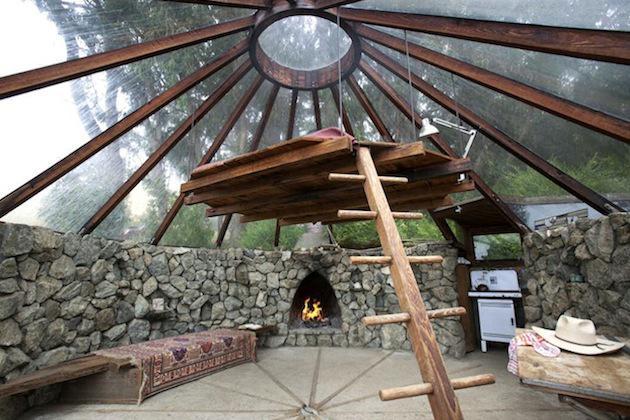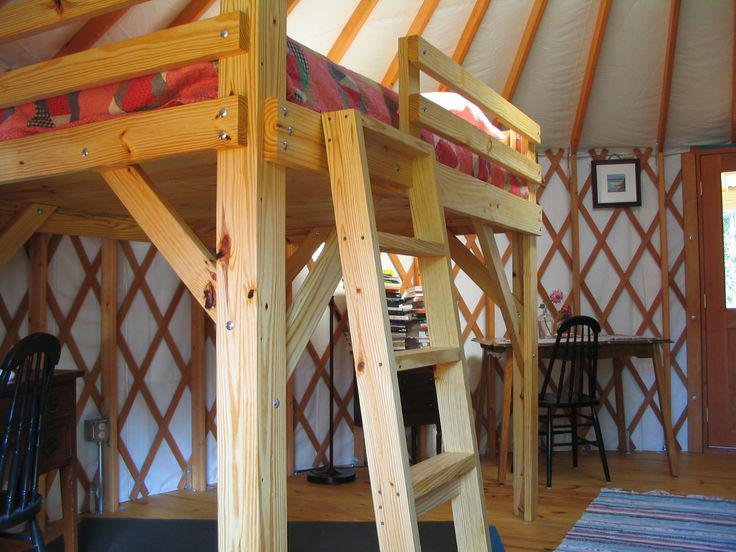The first image is the image on the left, the second image is the image on the right. Analyze the images presented: Is the assertion "A painting hangs on the wall in the image on the right." valid? Answer yes or no. Yes. The first image is the image on the left, the second image is the image on the right. For the images shown, is this caption "Left image shows a camera-facing ladder in front of a loft area with a railing of vertical posts." true? Answer yes or no. No. 